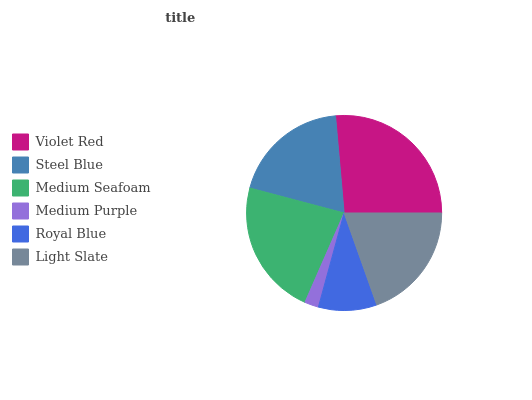Is Medium Purple the minimum?
Answer yes or no. Yes. Is Violet Red the maximum?
Answer yes or no. Yes. Is Steel Blue the minimum?
Answer yes or no. No. Is Steel Blue the maximum?
Answer yes or no. No. Is Violet Red greater than Steel Blue?
Answer yes or no. Yes. Is Steel Blue less than Violet Red?
Answer yes or no. Yes. Is Steel Blue greater than Violet Red?
Answer yes or no. No. Is Violet Red less than Steel Blue?
Answer yes or no. No. Is Light Slate the high median?
Answer yes or no. Yes. Is Steel Blue the low median?
Answer yes or no. Yes. Is Violet Red the high median?
Answer yes or no. No. Is Medium Seafoam the low median?
Answer yes or no. No. 